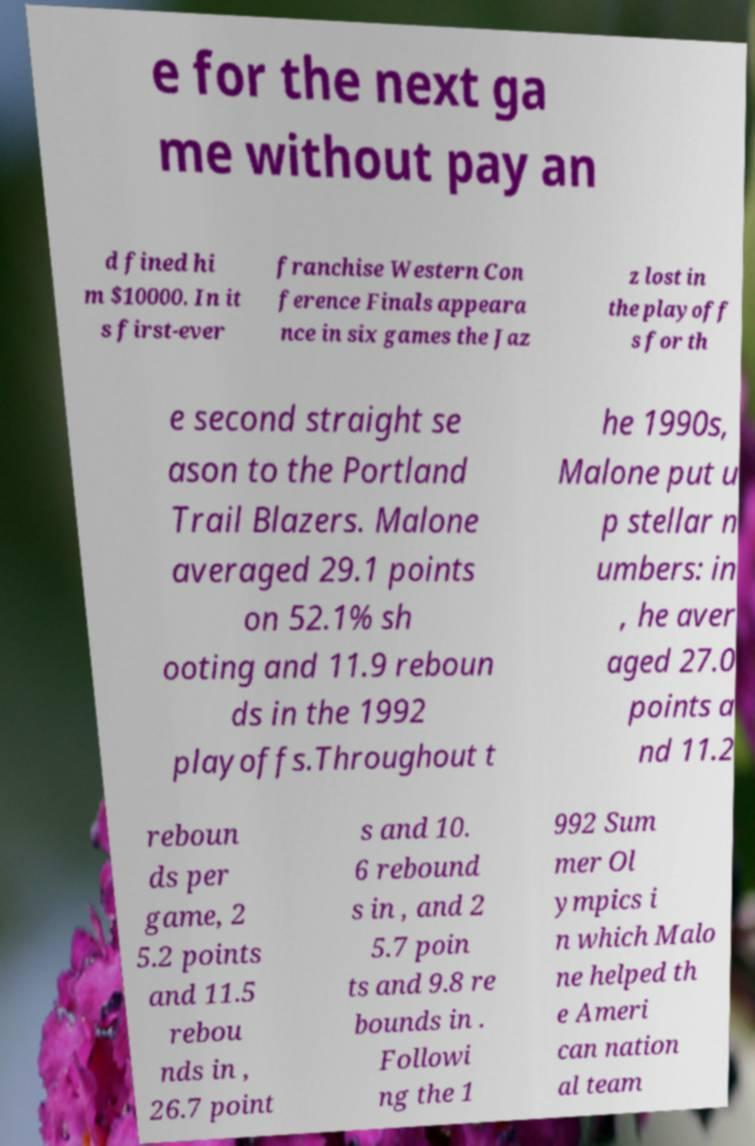I need the written content from this picture converted into text. Can you do that? e for the next ga me without pay an d fined hi m $10000. In it s first-ever franchise Western Con ference Finals appeara nce in six games the Jaz z lost in the playoff s for th e second straight se ason to the Portland Trail Blazers. Malone averaged 29.1 points on 52.1% sh ooting and 11.9 reboun ds in the 1992 playoffs.Throughout t he 1990s, Malone put u p stellar n umbers: in , he aver aged 27.0 points a nd 11.2 reboun ds per game, 2 5.2 points and 11.5 rebou nds in , 26.7 point s and 10. 6 rebound s in , and 2 5.7 poin ts and 9.8 re bounds in . Followi ng the 1 992 Sum mer Ol ympics i n which Malo ne helped th e Ameri can nation al team 